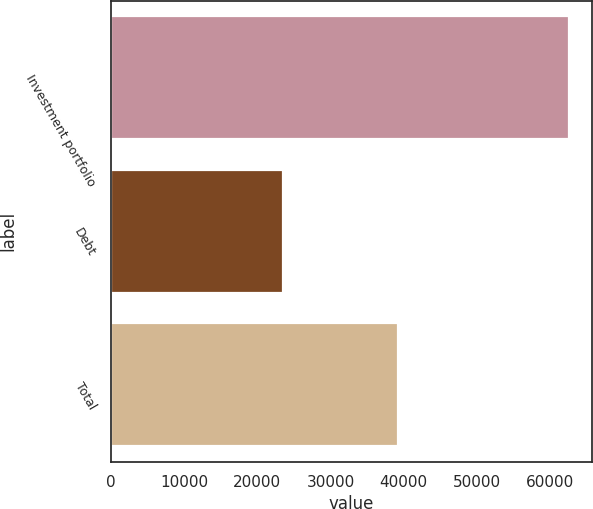Convert chart. <chart><loc_0><loc_0><loc_500><loc_500><bar_chart><fcel>Investment portfolio<fcel>Debt<fcel>Total<nl><fcel>62603<fcel>23449<fcel>39154<nl></chart> 